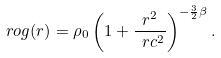<formula> <loc_0><loc_0><loc_500><loc_500>\ r o g ( r ) = \rho _ { 0 } \left ( 1 + \frac { r ^ { 2 } } { \ r c ^ { 2 } } \right ) ^ { - \frac { 3 } { 2 } \beta } .</formula> 